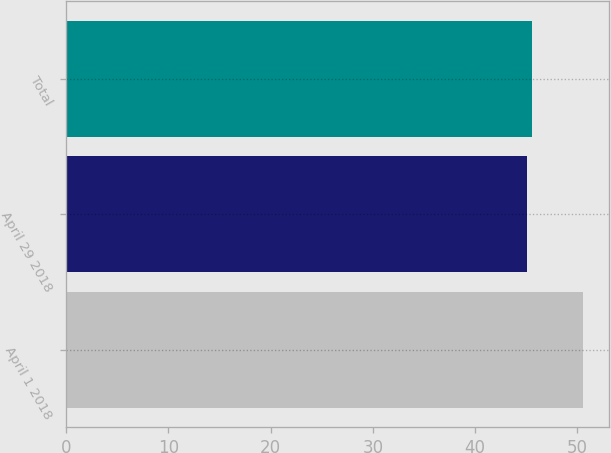<chart> <loc_0><loc_0><loc_500><loc_500><bar_chart><fcel>April 1 2018<fcel>April 29 2018<fcel>Total<nl><fcel>50.57<fcel>45.06<fcel>45.61<nl></chart> 